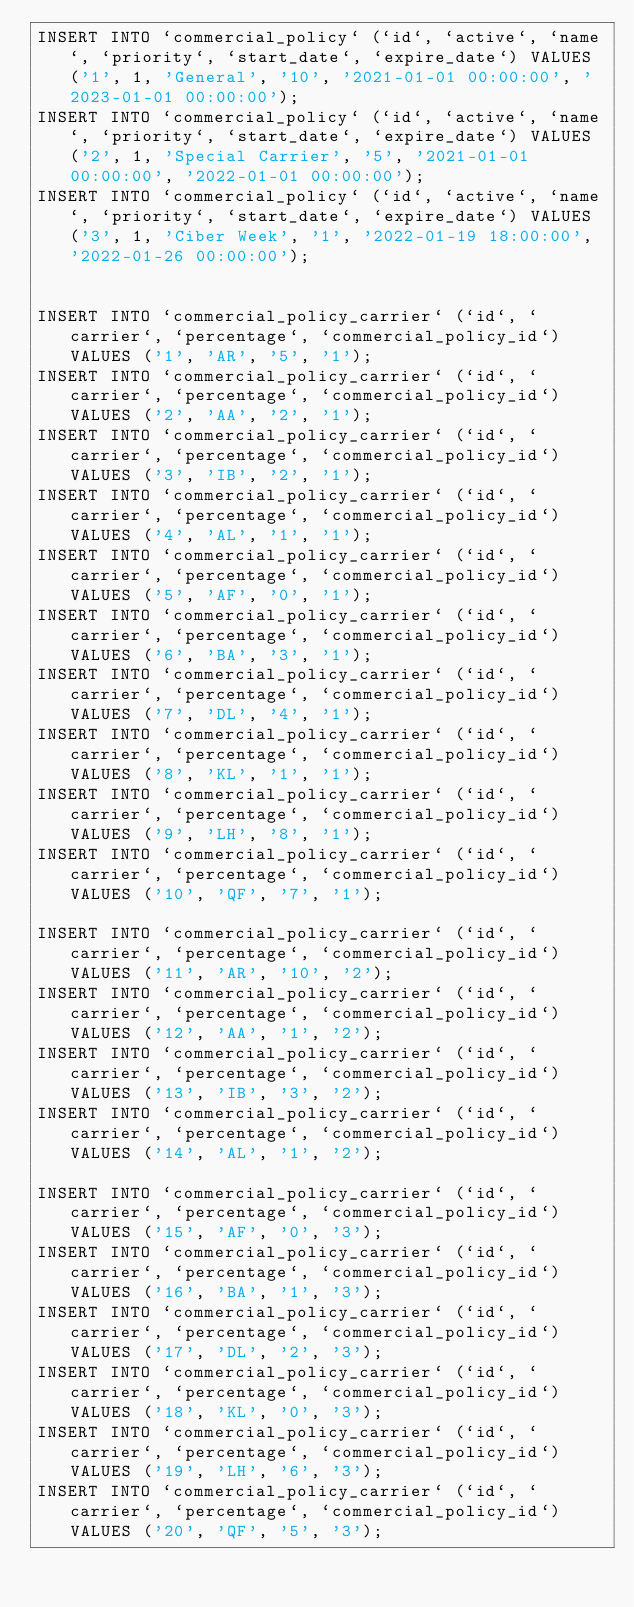<code> <loc_0><loc_0><loc_500><loc_500><_SQL_>INSERT INTO `commercial_policy` (`id`, `active`, `name`, `priority`, `start_date`, `expire_date`) VALUES ('1', 1, 'General', '10', '2021-01-01 00:00:00', '2023-01-01 00:00:00');
INSERT INTO `commercial_policy` (`id`, `active`, `name`, `priority`, `start_date`, `expire_date`) VALUES ('2', 1, 'Special Carrier', '5', '2021-01-01 00:00:00', '2022-01-01 00:00:00');
INSERT INTO `commercial_policy` (`id`, `active`, `name`, `priority`, `start_date`, `expire_date`) VALUES ('3', 1, 'Ciber Week', '1', '2022-01-19 18:00:00', '2022-01-26 00:00:00');


INSERT INTO `commercial_policy_carrier` (`id`, `carrier`, `percentage`, `commercial_policy_id`) VALUES ('1', 'AR', '5', '1');
INSERT INTO `commercial_policy_carrier` (`id`, `carrier`, `percentage`, `commercial_policy_id`) VALUES ('2', 'AA', '2', '1');
INSERT INTO `commercial_policy_carrier` (`id`, `carrier`, `percentage`, `commercial_policy_id`) VALUES ('3', 'IB', '2', '1');
INSERT INTO `commercial_policy_carrier` (`id`, `carrier`, `percentage`, `commercial_policy_id`) VALUES ('4', 'AL', '1', '1');
INSERT INTO `commercial_policy_carrier` (`id`, `carrier`, `percentage`, `commercial_policy_id`) VALUES ('5', 'AF', '0', '1');
INSERT INTO `commercial_policy_carrier` (`id`, `carrier`, `percentage`, `commercial_policy_id`) VALUES ('6', 'BA', '3', '1');
INSERT INTO `commercial_policy_carrier` (`id`, `carrier`, `percentage`, `commercial_policy_id`) VALUES ('7', 'DL', '4', '1');
INSERT INTO `commercial_policy_carrier` (`id`, `carrier`, `percentage`, `commercial_policy_id`) VALUES ('8', 'KL', '1', '1');
INSERT INTO `commercial_policy_carrier` (`id`, `carrier`, `percentage`, `commercial_policy_id`) VALUES ('9', 'LH', '8', '1');
INSERT INTO `commercial_policy_carrier` (`id`, `carrier`, `percentage`, `commercial_policy_id`) VALUES ('10', 'QF', '7', '1');

INSERT INTO `commercial_policy_carrier` (`id`, `carrier`, `percentage`, `commercial_policy_id`) VALUES ('11', 'AR', '10', '2');
INSERT INTO `commercial_policy_carrier` (`id`, `carrier`, `percentage`, `commercial_policy_id`) VALUES ('12', 'AA', '1', '2');
INSERT INTO `commercial_policy_carrier` (`id`, `carrier`, `percentage`, `commercial_policy_id`) VALUES ('13', 'IB', '3', '2');
INSERT INTO `commercial_policy_carrier` (`id`, `carrier`, `percentage`, `commercial_policy_id`) VALUES ('14', 'AL', '1', '2');

INSERT INTO `commercial_policy_carrier` (`id`, `carrier`, `percentage`, `commercial_policy_id`) VALUES ('15', 'AF', '0', '3');
INSERT INTO `commercial_policy_carrier` (`id`, `carrier`, `percentage`, `commercial_policy_id`) VALUES ('16', 'BA', '1', '3');
INSERT INTO `commercial_policy_carrier` (`id`, `carrier`, `percentage`, `commercial_policy_id`) VALUES ('17', 'DL', '2', '3');
INSERT INTO `commercial_policy_carrier` (`id`, `carrier`, `percentage`, `commercial_policy_id`) VALUES ('18', 'KL', '0', '3');
INSERT INTO `commercial_policy_carrier` (`id`, `carrier`, `percentage`, `commercial_policy_id`) VALUES ('19', 'LH', '6', '3');
INSERT INTO `commercial_policy_carrier` (`id`, `carrier`, `percentage`, `commercial_policy_id`) VALUES ('20', 'QF', '5', '3');
</code> 